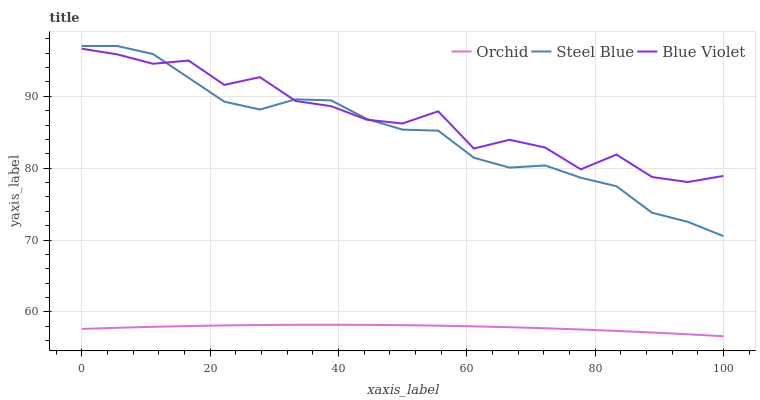Does Orchid have the minimum area under the curve?
Answer yes or no. Yes. Does Blue Violet have the maximum area under the curve?
Answer yes or no. Yes. Does Blue Violet have the minimum area under the curve?
Answer yes or no. No. Does Orchid have the maximum area under the curve?
Answer yes or no. No. Is Orchid the smoothest?
Answer yes or no. Yes. Is Blue Violet the roughest?
Answer yes or no. Yes. Is Blue Violet the smoothest?
Answer yes or no. No. Is Orchid the roughest?
Answer yes or no. No. Does Orchid have the lowest value?
Answer yes or no. Yes. Does Blue Violet have the lowest value?
Answer yes or no. No. Does Steel Blue have the highest value?
Answer yes or no. Yes. Does Blue Violet have the highest value?
Answer yes or no. No. Is Orchid less than Steel Blue?
Answer yes or no. Yes. Is Blue Violet greater than Orchid?
Answer yes or no. Yes. Does Blue Violet intersect Steel Blue?
Answer yes or no. Yes. Is Blue Violet less than Steel Blue?
Answer yes or no. No. Is Blue Violet greater than Steel Blue?
Answer yes or no. No. Does Orchid intersect Steel Blue?
Answer yes or no. No. 